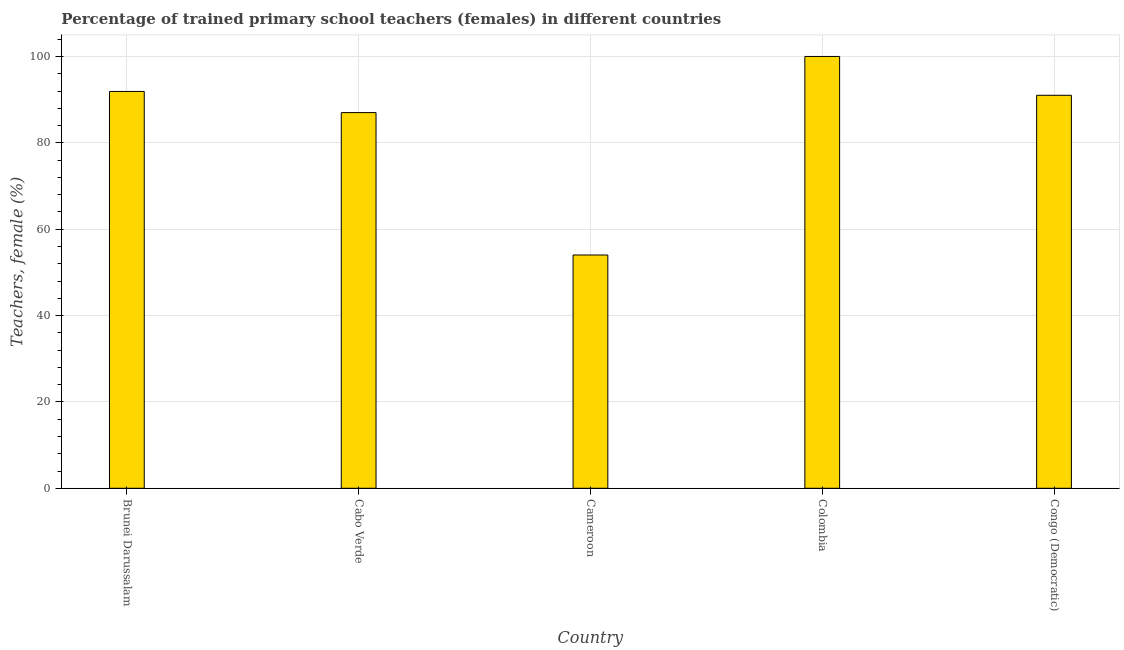Does the graph contain any zero values?
Make the answer very short. No. What is the title of the graph?
Give a very brief answer. Percentage of trained primary school teachers (females) in different countries. What is the label or title of the Y-axis?
Make the answer very short. Teachers, female (%). Across all countries, what is the maximum percentage of trained female teachers?
Your response must be concise. 100. Across all countries, what is the minimum percentage of trained female teachers?
Offer a very short reply. 54.02. In which country was the percentage of trained female teachers minimum?
Offer a terse response. Cameroon. What is the sum of the percentage of trained female teachers?
Provide a short and direct response. 423.93. What is the difference between the percentage of trained female teachers in Brunei Darussalam and Congo (Democratic)?
Your answer should be compact. 0.89. What is the average percentage of trained female teachers per country?
Your answer should be compact. 84.79. What is the median percentage of trained female teachers?
Offer a terse response. 91.01. In how many countries, is the percentage of trained female teachers greater than 92 %?
Your answer should be very brief. 1. What is the ratio of the percentage of trained female teachers in Cameroon to that in Colombia?
Provide a short and direct response. 0.54. Is the percentage of trained female teachers in Cabo Verde less than that in Colombia?
Give a very brief answer. Yes. Is the difference between the percentage of trained female teachers in Cameroon and Congo (Democratic) greater than the difference between any two countries?
Give a very brief answer. No. What is the difference between the highest and the second highest percentage of trained female teachers?
Make the answer very short. 8.1. Is the sum of the percentage of trained female teachers in Cabo Verde and Colombia greater than the maximum percentage of trained female teachers across all countries?
Your answer should be very brief. Yes. What is the difference between the highest and the lowest percentage of trained female teachers?
Your response must be concise. 45.98. Are all the bars in the graph horizontal?
Give a very brief answer. No. How many countries are there in the graph?
Give a very brief answer. 5. What is the difference between two consecutive major ticks on the Y-axis?
Your answer should be very brief. 20. What is the Teachers, female (%) in Brunei Darussalam?
Give a very brief answer. 91.9. What is the Teachers, female (%) in Cabo Verde?
Provide a succinct answer. 87. What is the Teachers, female (%) in Cameroon?
Offer a very short reply. 54.02. What is the Teachers, female (%) in Congo (Democratic)?
Your answer should be compact. 91.01. What is the difference between the Teachers, female (%) in Brunei Darussalam and Cabo Verde?
Offer a very short reply. 4.9. What is the difference between the Teachers, female (%) in Brunei Darussalam and Cameroon?
Offer a very short reply. 37.87. What is the difference between the Teachers, female (%) in Brunei Darussalam and Colombia?
Offer a very short reply. -8.1. What is the difference between the Teachers, female (%) in Brunei Darussalam and Congo (Democratic)?
Provide a succinct answer. 0.89. What is the difference between the Teachers, female (%) in Cabo Verde and Cameroon?
Ensure brevity in your answer.  32.98. What is the difference between the Teachers, female (%) in Cabo Verde and Colombia?
Keep it short and to the point. -13. What is the difference between the Teachers, female (%) in Cabo Verde and Congo (Democratic)?
Give a very brief answer. -4.01. What is the difference between the Teachers, female (%) in Cameroon and Colombia?
Provide a short and direct response. -45.98. What is the difference between the Teachers, female (%) in Cameroon and Congo (Democratic)?
Offer a terse response. -36.98. What is the difference between the Teachers, female (%) in Colombia and Congo (Democratic)?
Provide a succinct answer. 8.99. What is the ratio of the Teachers, female (%) in Brunei Darussalam to that in Cabo Verde?
Keep it short and to the point. 1.06. What is the ratio of the Teachers, female (%) in Brunei Darussalam to that in Cameroon?
Your answer should be very brief. 1.7. What is the ratio of the Teachers, female (%) in Brunei Darussalam to that in Colombia?
Ensure brevity in your answer.  0.92. What is the ratio of the Teachers, female (%) in Brunei Darussalam to that in Congo (Democratic)?
Ensure brevity in your answer.  1.01. What is the ratio of the Teachers, female (%) in Cabo Verde to that in Cameroon?
Your answer should be compact. 1.61. What is the ratio of the Teachers, female (%) in Cabo Verde to that in Colombia?
Provide a short and direct response. 0.87. What is the ratio of the Teachers, female (%) in Cabo Verde to that in Congo (Democratic)?
Ensure brevity in your answer.  0.96. What is the ratio of the Teachers, female (%) in Cameroon to that in Colombia?
Your answer should be very brief. 0.54. What is the ratio of the Teachers, female (%) in Cameroon to that in Congo (Democratic)?
Make the answer very short. 0.59. What is the ratio of the Teachers, female (%) in Colombia to that in Congo (Democratic)?
Provide a succinct answer. 1.1. 